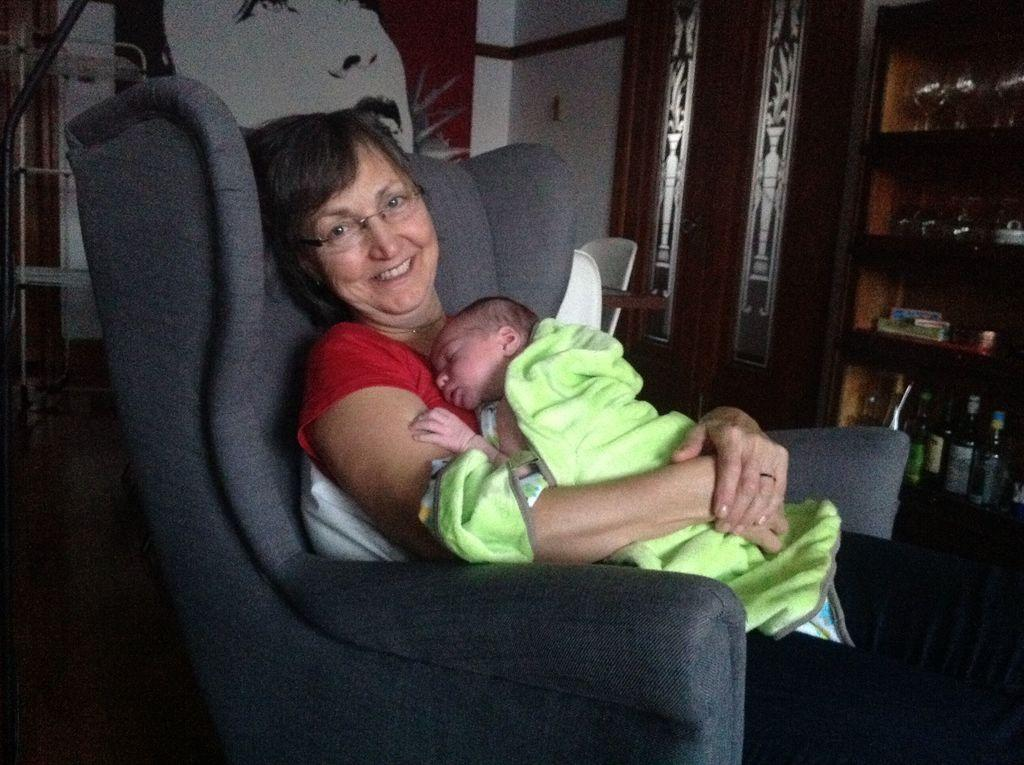What is the woman in the image doing? The woman is sitting on the sofa and holding a kid. What can be seen on the rack in the image? There are bottles and glasses on the rack. What type of architectural feature is visible in the image? There are doors visible in the image. What is the background of the image made of? There is a wall in the image. What type of knowledge can be seen on the pig in the image? There is no pig present in the image, so it is not possible to determine what type of knowledge might be seen on it. 